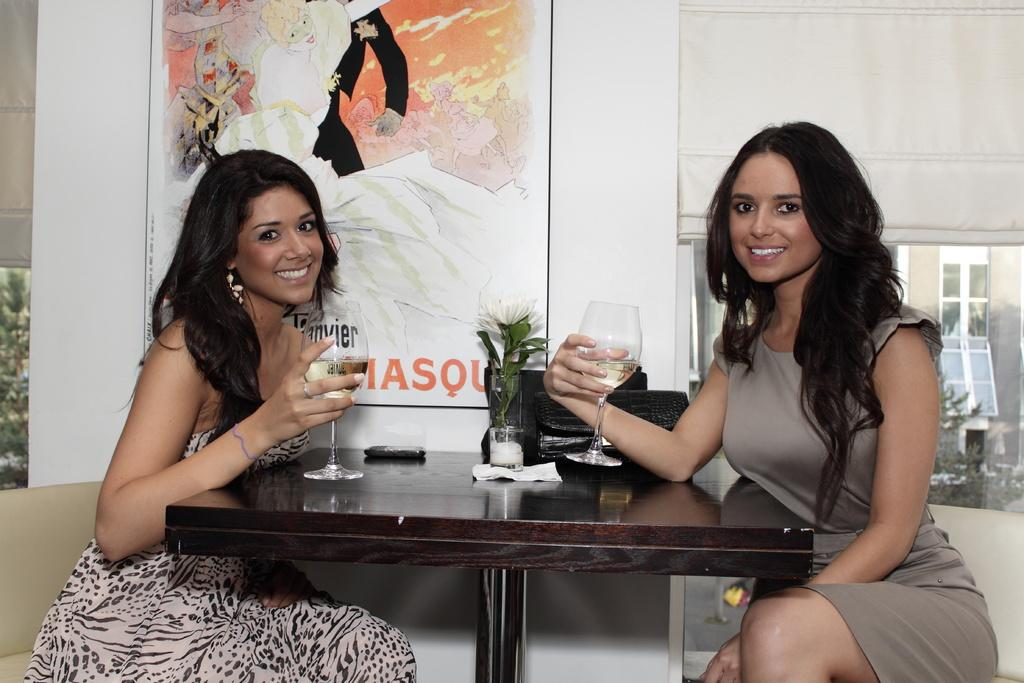How many people are in the image? There are two lady persons in the image. What are the lady persons doing in the image? The lady persons are sitting on chairs and having drinks. What can be seen in the background of the image? There is a painting in the background of the image. Can you tell me how many snails are crawling on the chairs in the image? There are no snails present in the image; the lady persons are sitting on chairs. What type of waste is visible in the image? There is no waste visible in the image; it features two lady persons sitting on chairs and having drinks. 